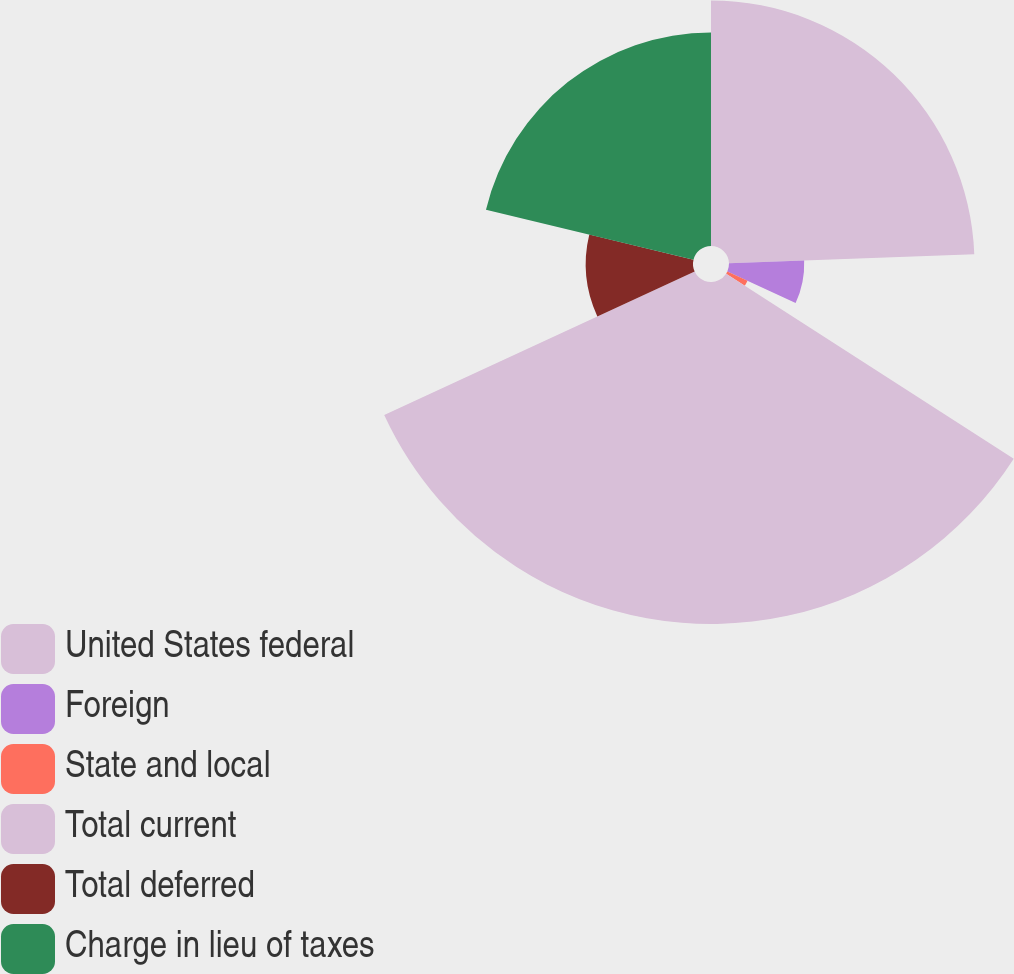Convert chart. <chart><loc_0><loc_0><loc_500><loc_500><pie_chart><fcel>United States federal<fcel>Foreign<fcel>State and local<fcel>Total current<fcel>Total deferred<fcel>Charge in lieu of taxes<nl><fcel>24.41%<fcel>7.48%<fcel>2.21%<fcel>34.01%<fcel>10.66%<fcel>21.23%<nl></chart> 